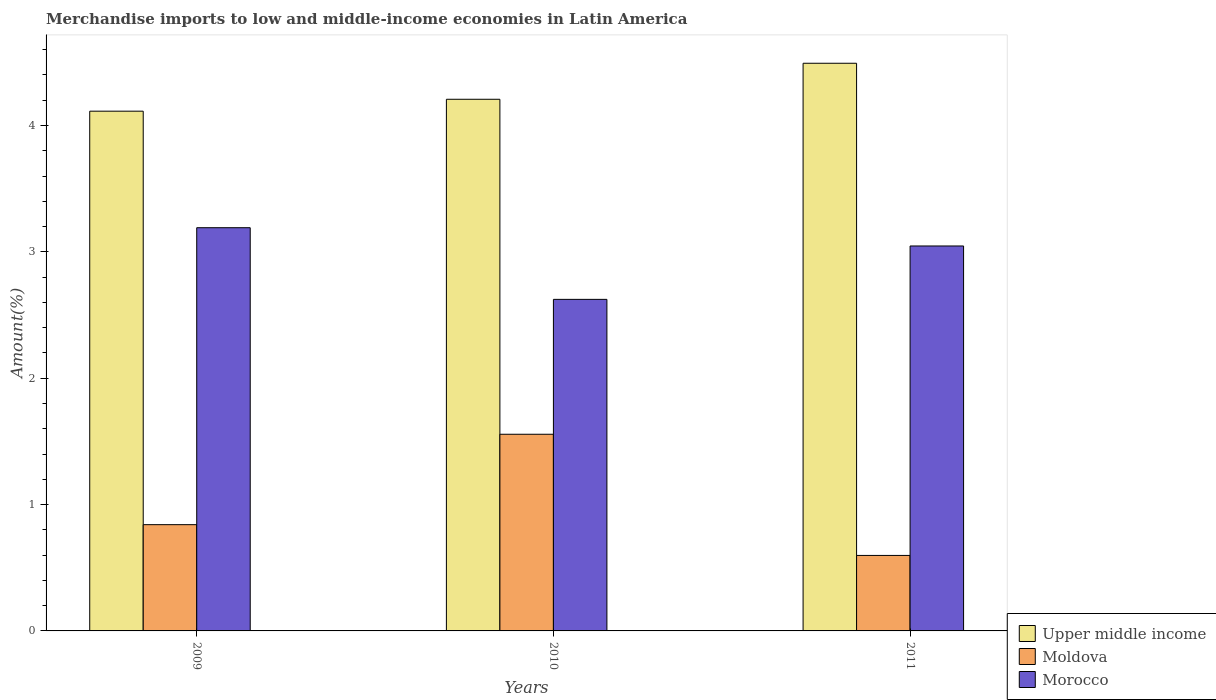How many different coloured bars are there?
Make the answer very short. 3. What is the label of the 3rd group of bars from the left?
Keep it short and to the point. 2011. In how many cases, is the number of bars for a given year not equal to the number of legend labels?
Offer a very short reply. 0. What is the percentage of amount earned from merchandise imports in Upper middle income in 2010?
Offer a very short reply. 4.21. Across all years, what is the maximum percentage of amount earned from merchandise imports in Moldova?
Your answer should be very brief. 1.56. Across all years, what is the minimum percentage of amount earned from merchandise imports in Morocco?
Offer a terse response. 2.62. In which year was the percentage of amount earned from merchandise imports in Upper middle income minimum?
Give a very brief answer. 2009. What is the total percentage of amount earned from merchandise imports in Morocco in the graph?
Make the answer very short. 8.86. What is the difference between the percentage of amount earned from merchandise imports in Moldova in 2009 and that in 2010?
Ensure brevity in your answer.  -0.72. What is the difference between the percentage of amount earned from merchandise imports in Morocco in 2010 and the percentage of amount earned from merchandise imports in Upper middle income in 2009?
Keep it short and to the point. -1.49. What is the average percentage of amount earned from merchandise imports in Upper middle income per year?
Keep it short and to the point. 4.27. In the year 2010, what is the difference between the percentage of amount earned from merchandise imports in Upper middle income and percentage of amount earned from merchandise imports in Moldova?
Make the answer very short. 2.65. In how many years, is the percentage of amount earned from merchandise imports in Upper middle income greater than 1.4 %?
Your answer should be very brief. 3. What is the ratio of the percentage of amount earned from merchandise imports in Upper middle income in 2009 to that in 2010?
Offer a very short reply. 0.98. What is the difference between the highest and the second highest percentage of amount earned from merchandise imports in Moldova?
Offer a terse response. 0.72. What is the difference between the highest and the lowest percentage of amount earned from merchandise imports in Moldova?
Offer a very short reply. 0.96. What does the 1st bar from the left in 2010 represents?
Offer a very short reply. Upper middle income. What does the 1st bar from the right in 2009 represents?
Keep it short and to the point. Morocco. Is it the case that in every year, the sum of the percentage of amount earned from merchandise imports in Moldova and percentage of amount earned from merchandise imports in Morocco is greater than the percentage of amount earned from merchandise imports in Upper middle income?
Offer a terse response. No. How many bars are there?
Give a very brief answer. 9. Are all the bars in the graph horizontal?
Offer a very short reply. No. How many years are there in the graph?
Make the answer very short. 3. Does the graph contain any zero values?
Your answer should be very brief. No. How are the legend labels stacked?
Keep it short and to the point. Vertical. What is the title of the graph?
Your answer should be compact. Merchandise imports to low and middle-income economies in Latin America. What is the label or title of the Y-axis?
Your response must be concise. Amount(%). What is the Amount(%) in Upper middle income in 2009?
Give a very brief answer. 4.11. What is the Amount(%) of Moldova in 2009?
Your answer should be very brief. 0.84. What is the Amount(%) of Morocco in 2009?
Keep it short and to the point. 3.19. What is the Amount(%) in Upper middle income in 2010?
Provide a short and direct response. 4.21. What is the Amount(%) of Moldova in 2010?
Provide a succinct answer. 1.56. What is the Amount(%) of Morocco in 2010?
Offer a very short reply. 2.62. What is the Amount(%) in Upper middle income in 2011?
Offer a terse response. 4.49. What is the Amount(%) of Moldova in 2011?
Your answer should be compact. 0.6. What is the Amount(%) of Morocco in 2011?
Make the answer very short. 3.05. Across all years, what is the maximum Amount(%) of Upper middle income?
Offer a terse response. 4.49. Across all years, what is the maximum Amount(%) in Moldova?
Provide a succinct answer. 1.56. Across all years, what is the maximum Amount(%) of Morocco?
Provide a short and direct response. 3.19. Across all years, what is the minimum Amount(%) in Upper middle income?
Ensure brevity in your answer.  4.11. Across all years, what is the minimum Amount(%) in Moldova?
Offer a terse response. 0.6. Across all years, what is the minimum Amount(%) in Morocco?
Your answer should be compact. 2.62. What is the total Amount(%) of Upper middle income in the graph?
Offer a very short reply. 12.81. What is the total Amount(%) in Moldova in the graph?
Offer a terse response. 2.99. What is the total Amount(%) in Morocco in the graph?
Offer a very short reply. 8.86. What is the difference between the Amount(%) of Upper middle income in 2009 and that in 2010?
Your response must be concise. -0.09. What is the difference between the Amount(%) in Moldova in 2009 and that in 2010?
Provide a succinct answer. -0.72. What is the difference between the Amount(%) in Morocco in 2009 and that in 2010?
Your answer should be very brief. 0.57. What is the difference between the Amount(%) in Upper middle income in 2009 and that in 2011?
Your answer should be very brief. -0.38. What is the difference between the Amount(%) of Moldova in 2009 and that in 2011?
Offer a terse response. 0.24. What is the difference between the Amount(%) in Morocco in 2009 and that in 2011?
Provide a succinct answer. 0.14. What is the difference between the Amount(%) of Upper middle income in 2010 and that in 2011?
Ensure brevity in your answer.  -0.28. What is the difference between the Amount(%) of Morocco in 2010 and that in 2011?
Ensure brevity in your answer.  -0.42. What is the difference between the Amount(%) in Upper middle income in 2009 and the Amount(%) in Moldova in 2010?
Offer a very short reply. 2.56. What is the difference between the Amount(%) in Upper middle income in 2009 and the Amount(%) in Morocco in 2010?
Keep it short and to the point. 1.49. What is the difference between the Amount(%) of Moldova in 2009 and the Amount(%) of Morocco in 2010?
Your answer should be compact. -1.78. What is the difference between the Amount(%) of Upper middle income in 2009 and the Amount(%) of Moldova in 2011?
Your answer should be very brief. 3.52. What is the difference between the Amount(%) of Upper middle income in 2009 and the Amount(%) of Morocco in 2011?
Provide a short and direct response. 1.07. What is the difference between the Amount(%) of Moldova in 2009 and the Amount(%) of Morocco in 2011?
Keep it short and to the point. -2.21. What is the difference between the Amount(%) of Upper middle income in 2010 and the Amount(%) of Moldova in 2011?
Offer a very short reply. 3.61. What is the difference between the Amount(%) of Upper middle income in 2010 and the Amount(%) of Morocco in 2011?
Provide a short and direct response. 1.16. What is the difference between the Amount(%) of Moldova in 2010 and the Amount(%) of Morocco in 2011?
Make the answer very short. -1.49. What is the average Amount(%) in Upper middle income per year?
Make the answer very short. 4.27. What is the average Amount(%) in Moldova per year?
Your answer should be compact. 1. What is the average Amount(%) in Morocco per year?
Provide a succinct answer. 2.95. In the year 2009, what is the difference between the Amount(%) of Upper middle income and Amount(%) of Moldova?
Make the answer very short. 3.27. In the year 2009, what is the difference between the Amount(%) of Upper middle income and Amount(%) of Morocco?
Your answer should be compact. 0.92. In the year 2009, what is the difference between the Amount(%) of Moldova and Amount(%) of Morocco?
Provide a short and direct response. -2.35. In the year 2010, what is the difference between the Amount(%) in Upper middle income and Amount(%) in Moldova?
Offer a terse response. 2.65. In the year 2010, what is the difference between the Amount(%) of Upper middle income and Amount(%) of Morocco?
Offer a very short reply. 1.58. In the year 2010, what is the difference between the Amount(%) in Moldova and Amount(%) in Morocco?
Offer a terse response. -1.07. In the year 2011, what is the difference between the Amount(%) of Upper middle income and Amount(%) of Moldova?
Ensure brevity in your answer.  3.9. In the year 2011, what is the difference between the Amount(%) of Upper middle income and Amount(%) of Morocco?
Your answer should be compact. 1.45. In the year 2011, what is the difference between the Amount(%) in Moldova and Amount(%) in Morocco?
Give a very brief answer. -2.45. What is the ratio of the Amount(%) of Upper middle income in 2009 to that in 2010?
Your answer should be compact. 0.98. What is the ratio of the Amount(%) of Moldova in 2009 to that in 2010?
Give a very brief answer. 0.54. What is the ratio of the Amount(%) of Morocco in 2009 to that in 2010?
Make the answer very short. 1.22. What is the ratio of the Amount(%) in Upper middle income in 2009 to that in 2011?
Keep it short and to the point. 0.92. What is the ratio of the Amount(%) of Moldova in 2009 to that in 2011?
Give a very brief answer. 1.41. What is the ratio of the Amount(%) of Morocco in 2009 to that in 2011?
Offer a terse response. 1.05. What is the ratio of the Amount(%) in Upper middle income in 2010 to that in 2011?
Your answer should be very brief. 0.94. What is the ratio of the Amount(%) of Moldova in 2010 to that in 2011?
Your response must be concise. 2.61. What is the ratio of the Amount(%) in Morocco in 2010 to that in 2011?
Your response must be concise. 0.86. What is the difference between the highest and the second highest Amount(%) in Upper middle income?
Your response must be concise. 0.28. What is the difference between the highest and the second highest Amount(%) in Moldova?
Your response must be concise. 0.72. What is the difference between the highest and the second highest Amount(%) in Morocco?
Provide a succinct answer. 0.14. What is the difference between the highest and the lowest Amount(%) in Upper middle income?
Your answer should be very brief. 0.38. What is the difference between the highest and the lowest Amount(%) in Moldova?
Offer a very short reply. 0.96. What is the difference between the highest and the lowest Amount(%) in Morocco?
Ensure brevity in your answer.  0.57. 